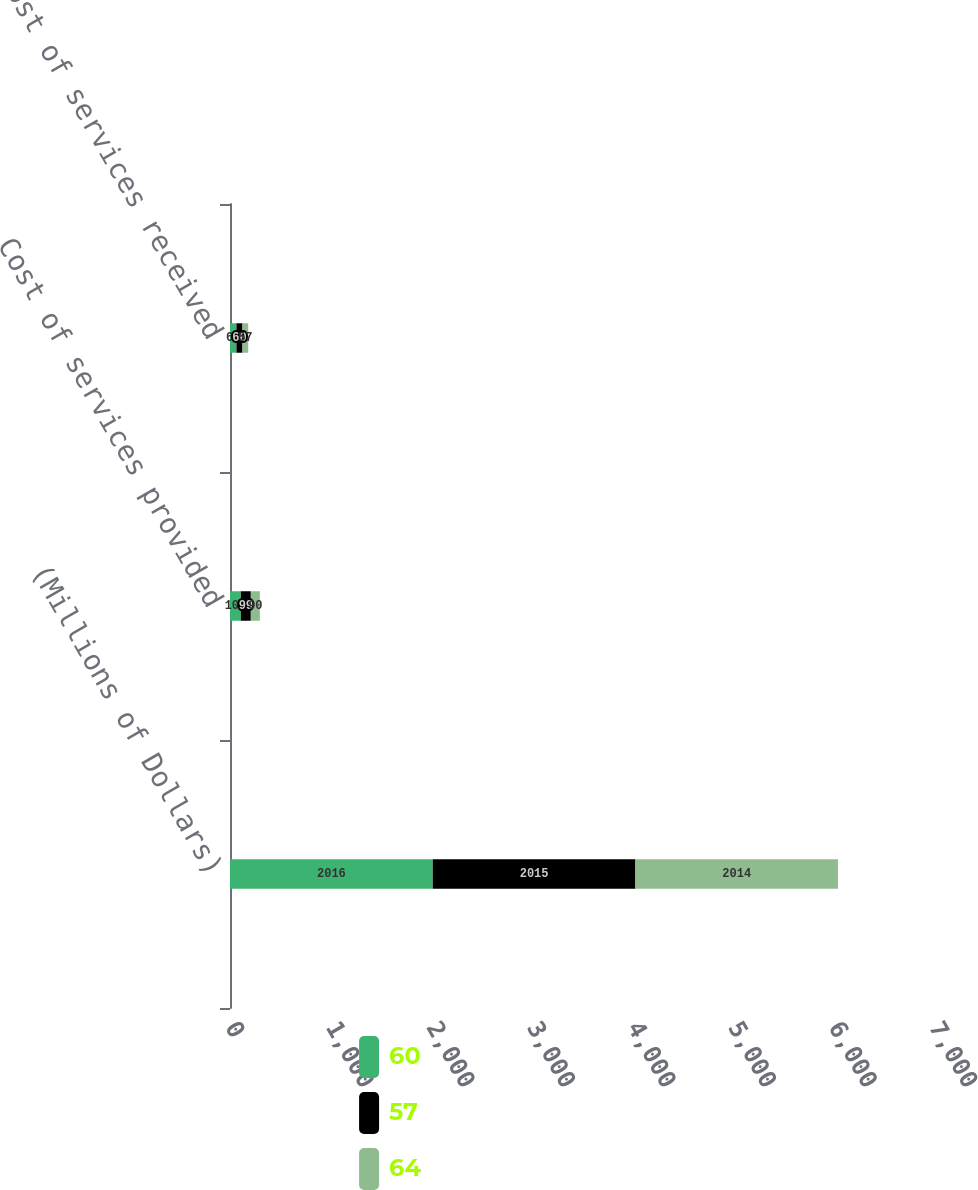<chart> <loc_0><loc_0><loc_500><loc_500><stacked_bar_chart><ecel><fcel>(Millions of Dollars)<fcel>Cost of services provided<fcel>Cost of services received<nl><fcel>60<fcel>2016<fcel>108<fcel>64<nl><fcel>57<fcel>2015<fcel>99<fcel>60<nl><fcel>64<fcel>2014<fcel>90<fcel>57<nl></chart> 